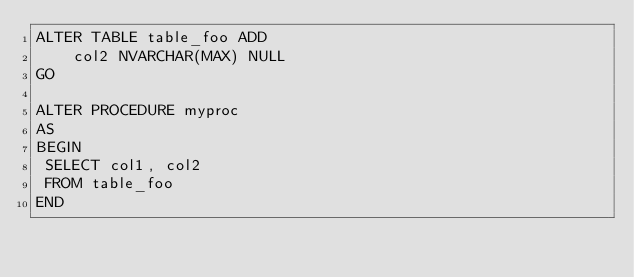Convert code to text. <code><loc_0><loc_0><loc_500><loc_500><_SQL_>ALTER TABLE table_foo ADD
    col2 NVARCHAR(MAX) NULL
GO

ALTER PROCEDURE myproc
AS
BEGIN
 SELECT col1, col2
 FROM table_foo
END
</code> 